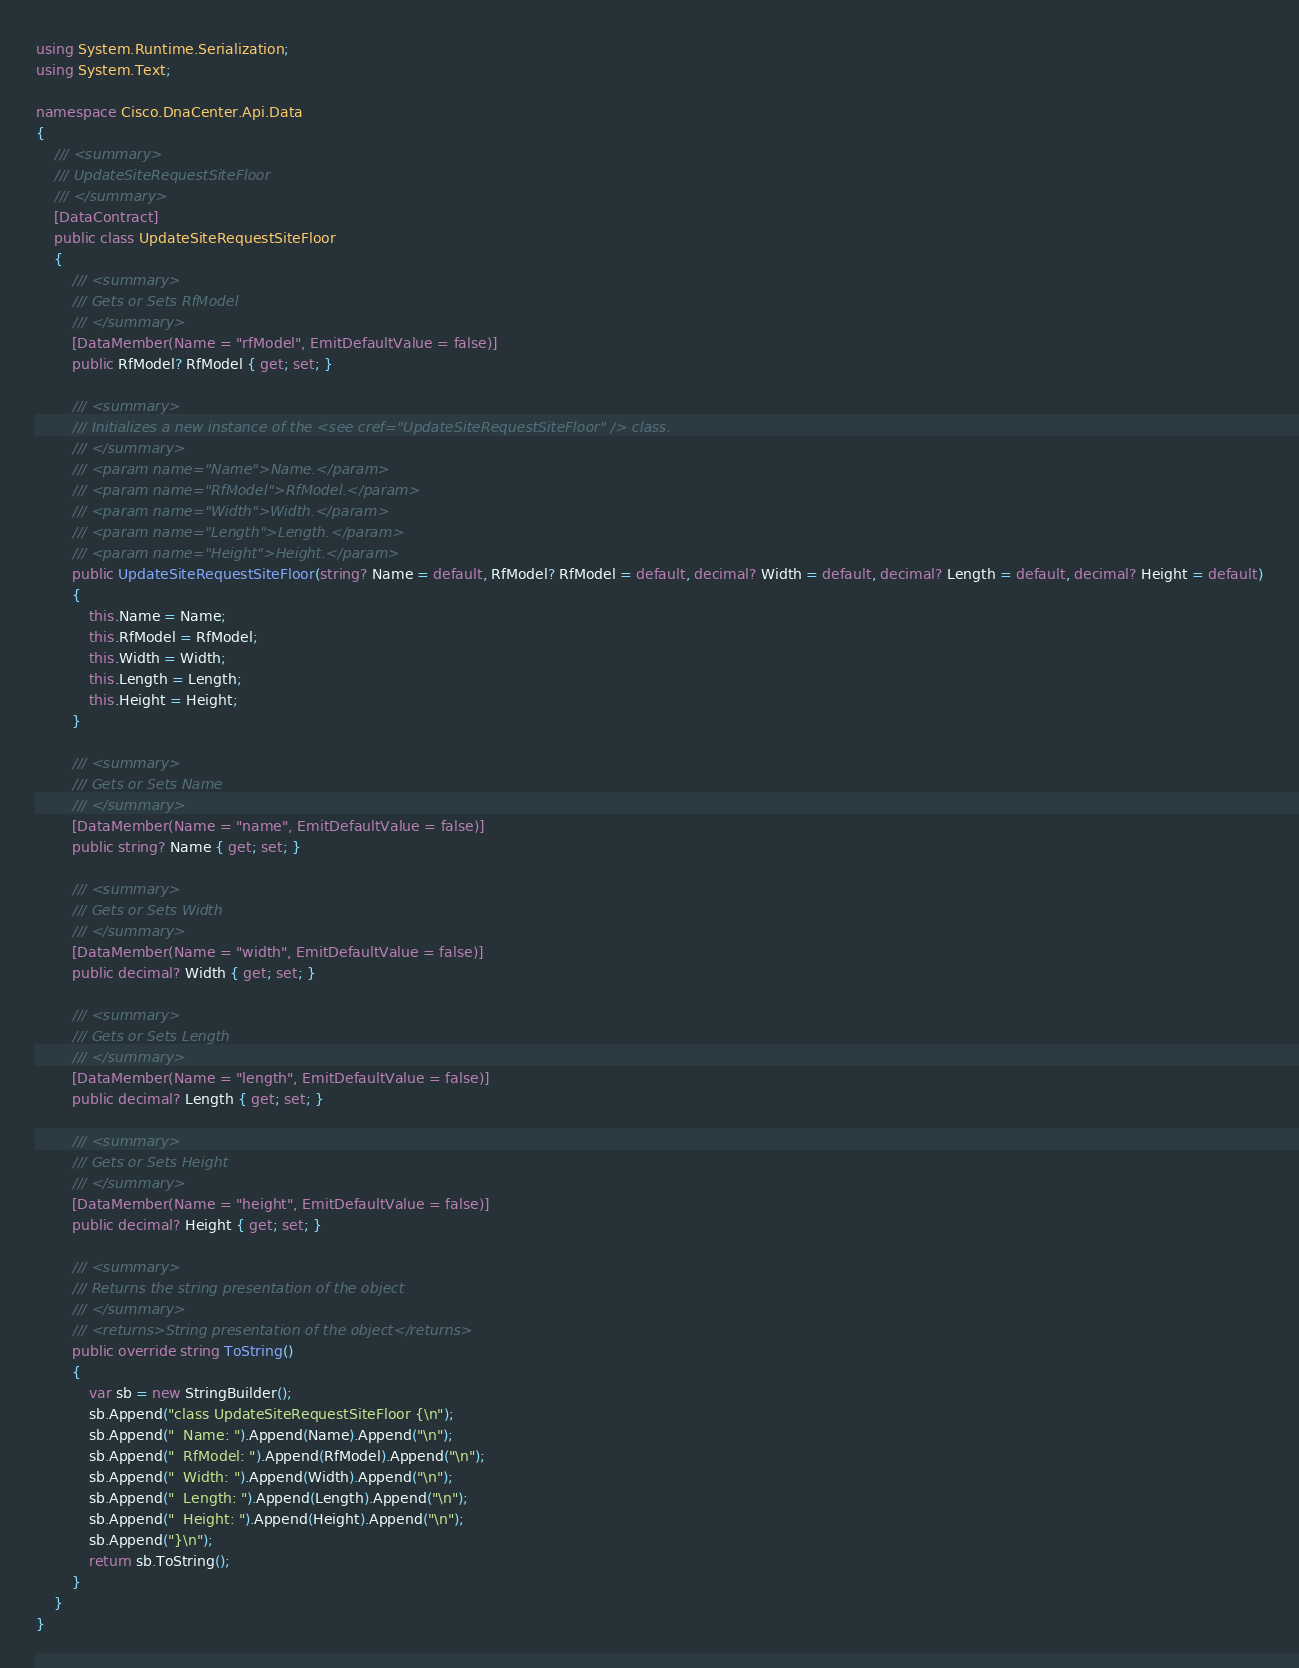<code> <loc_0><loc_0><loc_500><loc_500><_C#_>using System.Runtime.Serialization;
using System.Text;

namespace Cisco.DnaCenter.Api.Data
{
	/// <summary>
	/// UpdateSiteRequestSiteFloor
	/// </summary>
	[DataContract]
	public class UpdateSiteRequestSiteFloor
	{
		/// <summary>
		/// Gets or Sets RfModel
		/// </summary>
		[DataMember(Name = "rfModel", EmitDefaultValue = false)]
		public RfModel? RfModel { get; set; }

		/// <summary>
		/// Initializes a new instance of the <see cref="UpdateSiteRequestSiteFloor" /> class.
		/// </summary>
		/// <param name="Name">Name.</param>
		/// <param name="RfModel">RfModel.</param>
		/// <param name="Width">Width.</param>
		/// <param name="Length">Length.</param>
		/// <param name="Height">Height.</param>
		public UpdateSiteRequestSiteFloor(string? Name = default, RfModel? RfModel = default, decimal? Width = default, decimal? Length = default, decimal? Height = default)
		{
			this.Name = Name;
			this.RfModel = RfModel;
			this.Width = Width;
			this.Length = Length;
			this.Height = Height;
		}

		/// <summary>
		/// Gets or Sets Name
		/// </summary>
		[DataMember(Name = "name", EmitDefaultValue = false)]
		public string? Name { get; set; }

		/// <summary>
		/// Gets or Sets Width
		/// </summary>
		[DataMember(Name = "width", EmitDefaultValue = false)]
		public decimal? Width { get; set; }

		/// <summary>
		/// Gets or Sets Length
		/// </summary>
		[DataMember(Name = "length", EmitDefaultValue = false)]
		public decimal? Length { get; set; }

		/// <summary>
		/// Gets or Sets Height
		/// </summary>
		[DataMember(Name = "height", EmitDefaultValue = false)]
		public decimal? Height { get; set; }

		/// <summary>
		/// Returns the string presentation of the object
		/// </summary>
		/// <returns>String presentation of the object</returns>
		public override string ToString()
		{
			var sb = new StringBuilder();
			sb.Append("class UpdateSiteRequestSiteFloor {\n");
			sb.Append("  Name: ").Append(Name).Append("\n");
			sb.Append("  RfModel: ").Append(RfModel).Append("\n");
			sb.Append("  Width: ").Append(Width).Append("\n");
			sb.Append("  Length: ").Append(Length).Append("\n");
			sb.Append("  Height: ").Append(Height).Append("\n");
			sb.Append("}\n");
			return sb.ToString();
		}
	}
}
</code> 